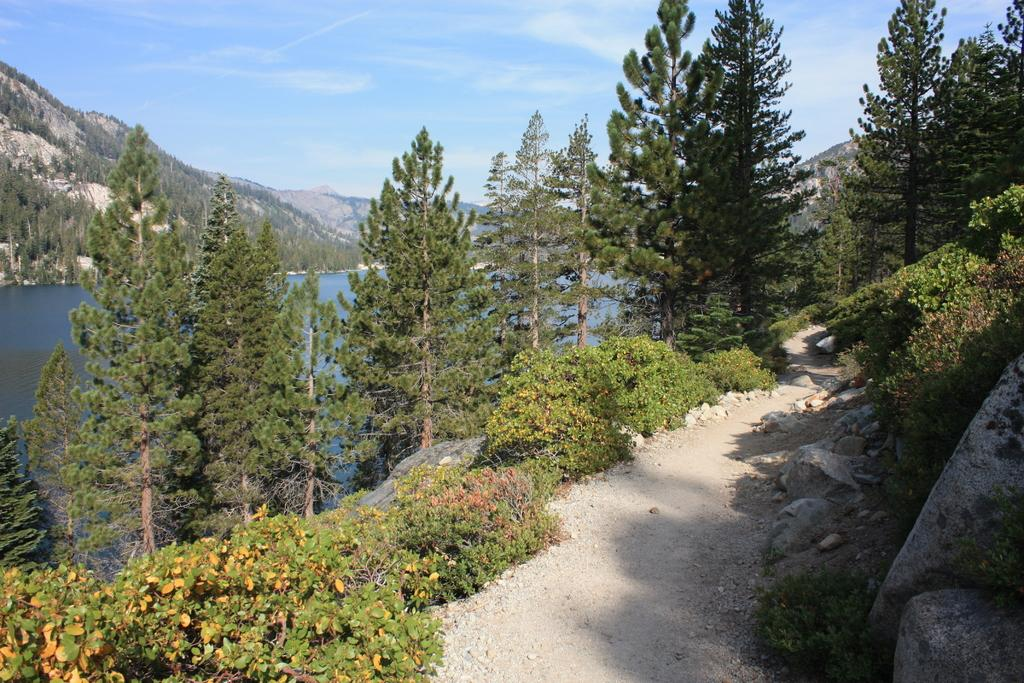What type of terrain can be seen in the image? There is a pathway, rocks, and bushes visible in the image. What can be seen in the background of the image? Trees, water, mountains, and the sky are visible in the background of the image. How many different types of natural features are present in the image? There are at least five different types of natural features present in the image: pathway, rocks, bushes, trees, and water. How does the impulse affect the credit score of the rocks in the image? There is no mention of impulse or credit score in the image, as it features a natural landscape with a pathway, rocks, bushes, trees, water, mountains, and the sky. 